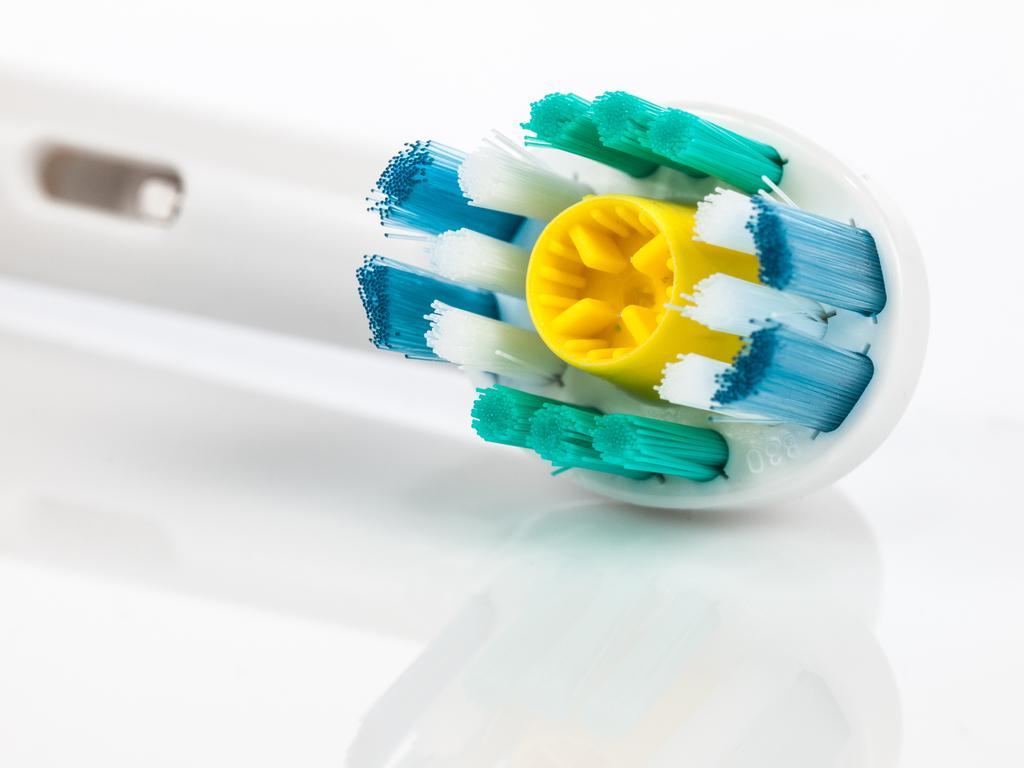In one or two sentences, can you explain what this image depicts? In this image there is a brush with a handle. 